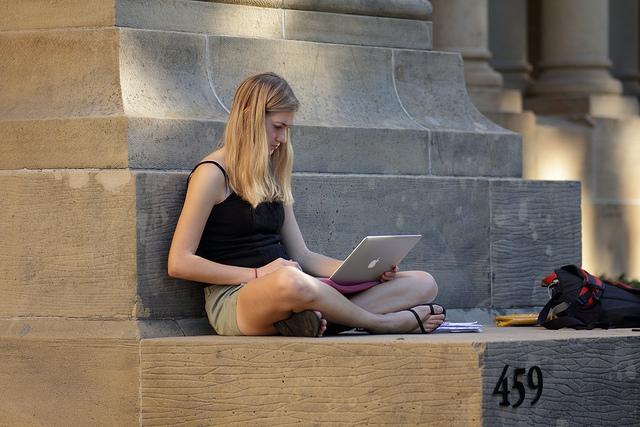What number is on the sidewalk?
Concise answer only. 459. What brand is the laptop?
Concise answer only. Apple. Where is the woman?
Be succinct. Outside. 